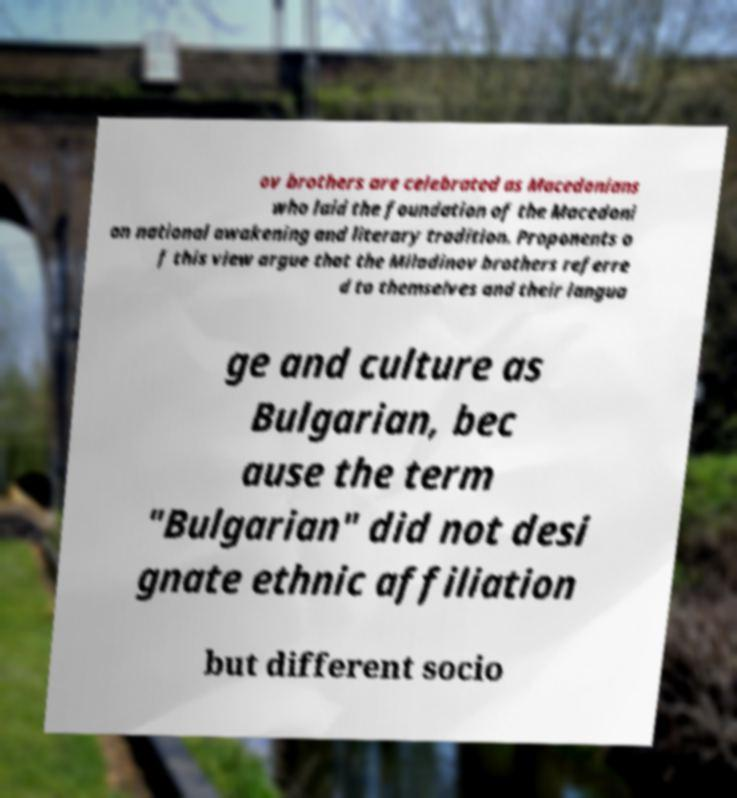I need the written content from this picture converted into text. Can you do that? ov brothers are celebrated as Macedonians who laid the foundation of the Macedoni an national awakening and literary tradition. Proponents o f this view argue that the Miladinov brothers referre d to themselves and their langua ge and culture as Bulgarian, bec ause the term "Bulgarian" did not desi gnate ethnic affiliation but different socio 